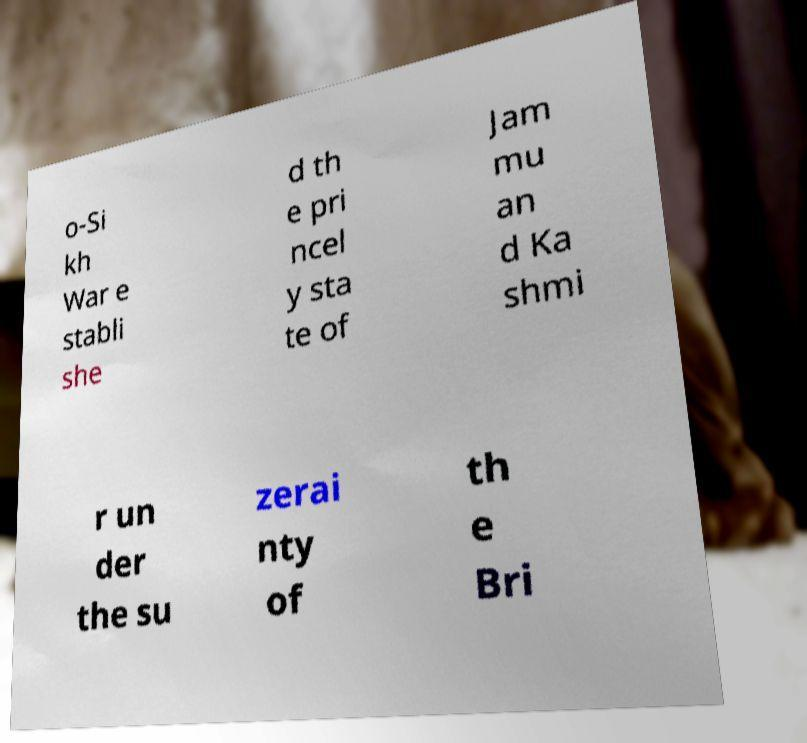Please read and relay the text visible in this image. What does it say? o-Si kh War e stabli she d th e pri ncel y sta te of Jam mu an d Ka shmi r un der the su zerai nty of th e Bri 